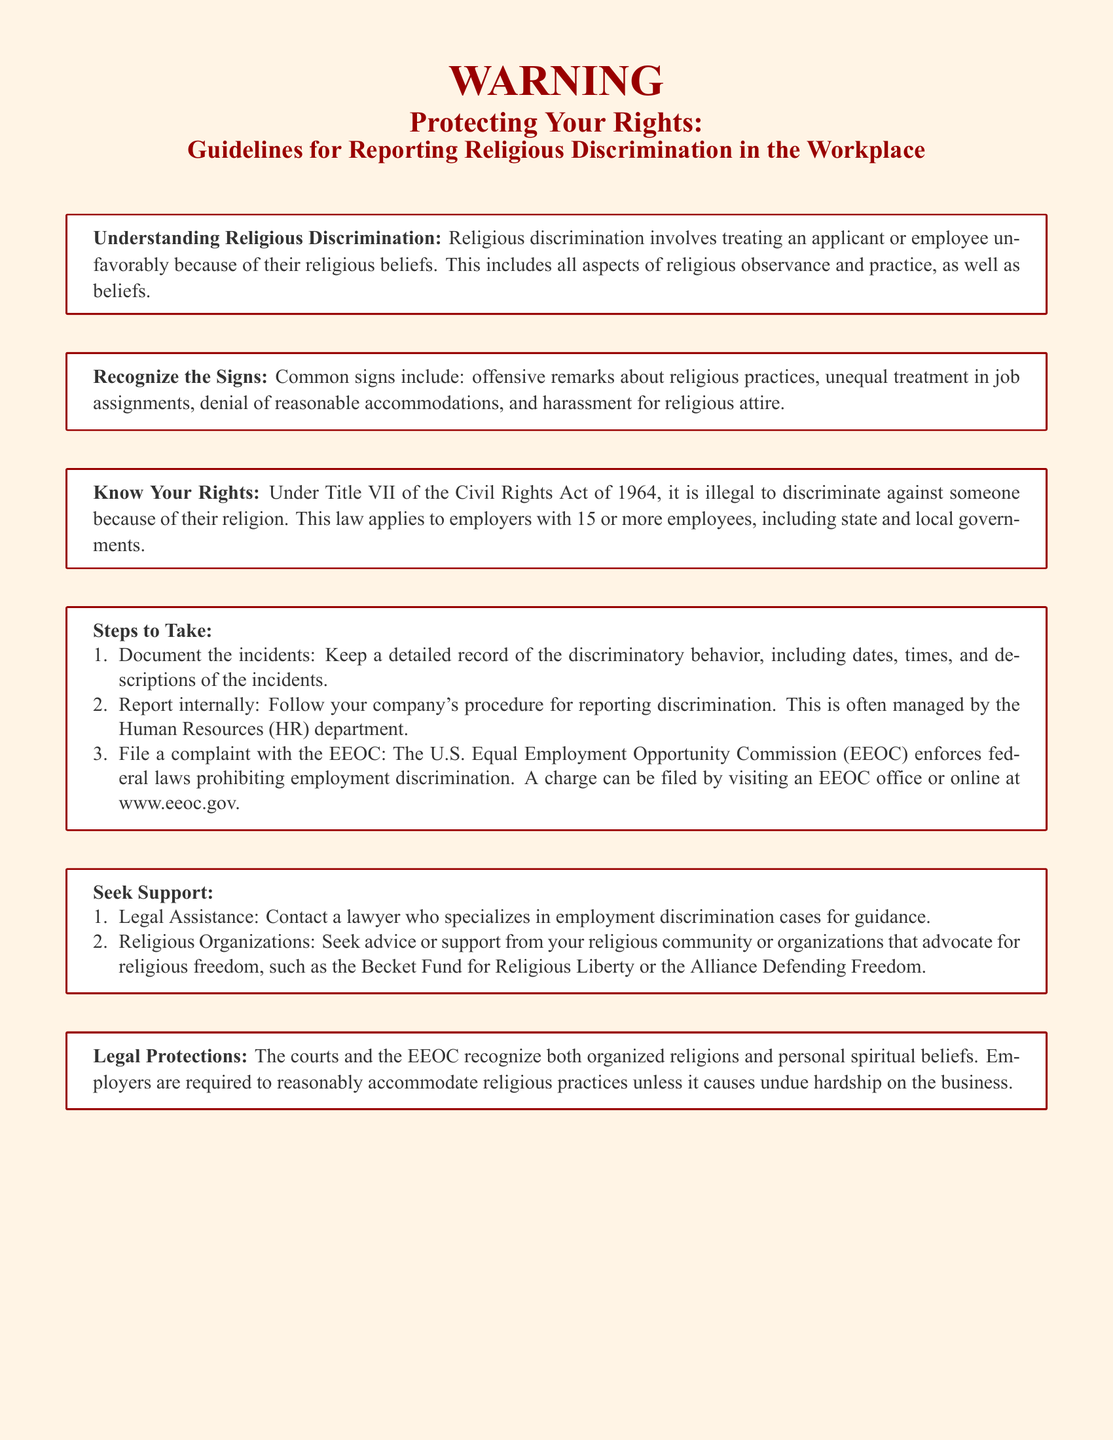What is religious discrimination? Religious discrimination involves treating an applicant or employee unfavorably because of their religious beliefs.
Answer: Treating an applicant or employee unfavorably because of their religious beliefs What law prohibits discrimination based on religion? Under Title VII of the Civil Rights Act of 1964, it is illegal to discriminate against someone because of their religion.
Answer: Title VII of the Civil Rights Act of 1964 What are two common signs of religious discrimination? The document lists offensive remarks about religious practices and unequal treatment in job assignments as common signs.
Answer: Offensive remarks about religious practices, unequal treatment in job assignments How many employees must an employer have for this law to apply? The document specifies that the law applies to employers with 15 or more employees.
Answer: 15 What should you do to report discrimination internally? According to the document, you should follow your company's procedure for reporting discrimination.
Answer: Follow your company's procedure for reporting discrimination Which organization enforces federal laws prohibiting employment discrimination? The document states that the U.S. Equal Employment Opportunity Commission (EEOC) enforces these laws.
Answer: U.S. Equal Employment Opportunity Commission (EEOC) What is the first step to take if you experience religious discrimination? The first step mentioned in the document is to document the incidents.
Answer: Document the incidents Name one type of assistance you can seek for support. Legal assistance is one of the types of support mentioned in the document.
Answer: Legal Assistance 